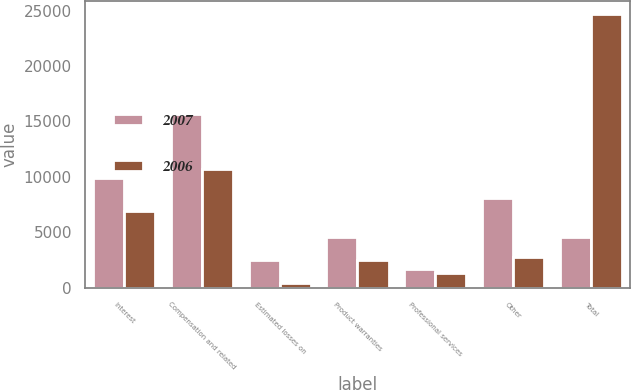<chart> <loc_0><loc_0><loc_500><loc_500><stacked_bar_chart><ecel><fcel>Interest<fcel>Compensation and related<fcel>Estimated losses on<fcel>Product warranties<fcel>Professional services<fcel>Other<fcel>Total<nl><fcel>2007<fcel>9930<fcel>15651<fcel>2498<fcel>4624<fcel>1667<fcel>8096<fcel>4624<nl><fcel>2006<fcel>6913<fcel>10719<fcel>421<fcel>2472<fcel>1373<fcel>2777<fcel>24675<nl></chart> 